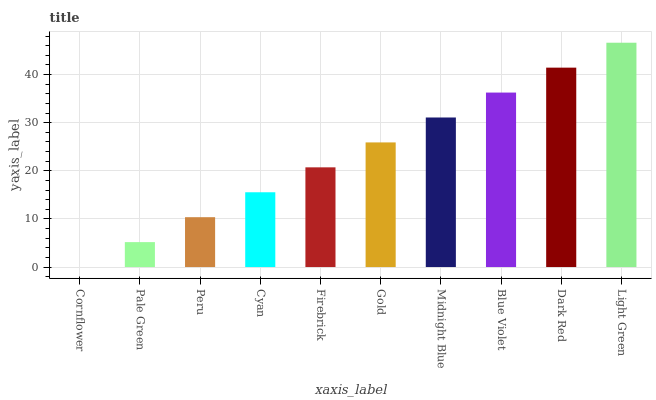Is Cornflower the minimum?
Answer yes or no. Yes. Is Light Green the maximum?
Answer yes or no. Yes. Is Pale Green the minimum?
Answer yes or no. No. Is Pale Green the maximum?
Answer yes or no. No. Is Pale Green greater than Cornflower?
Answer yes or no. Yes. Is Cornflower less than Pale Green?
Answer yes or no. Yes. Is Cornflower greater than Pale Green?
Answer yes or no. No. Is Pale Green less than Cornflower?
Answer yes or no. No. Is Gold the high median?
Answer yes or no. Yes. Is Firebrick the low median?
Answer yes or no. Yes. Is Peru the high median?
Answer yes or no. No. Is Blue Violet the low median?
Answer yes or no. No. 